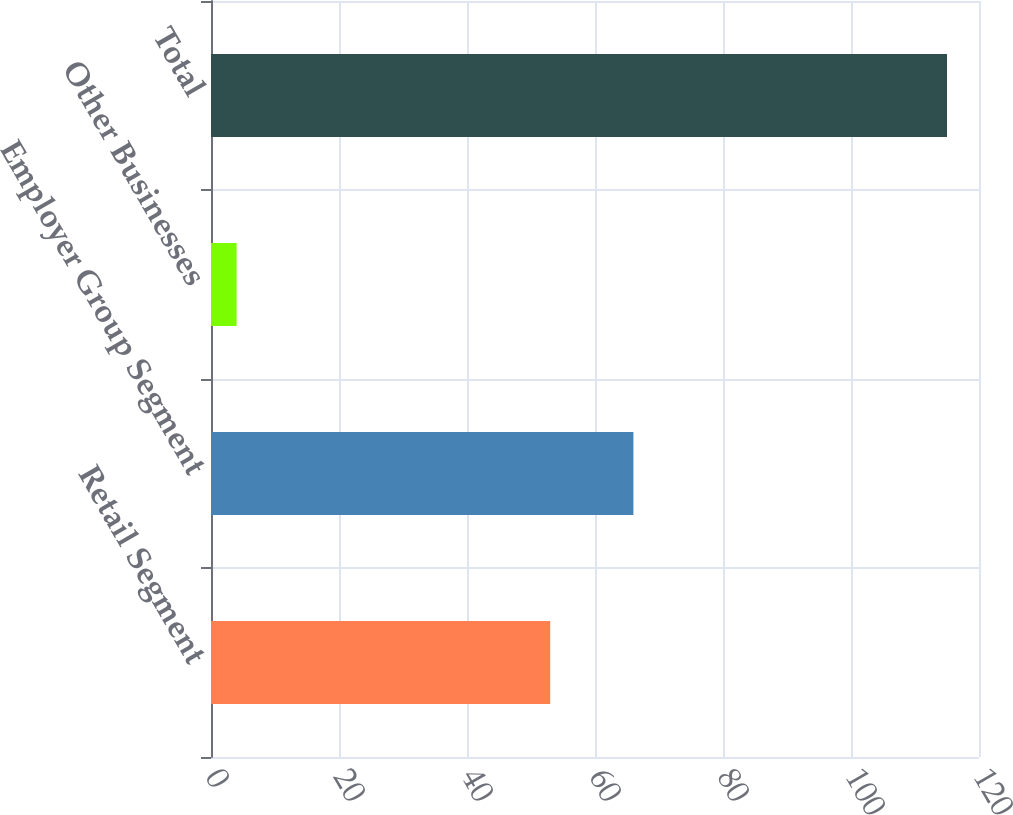Convert chart to OTSL. <chart><loc_0><loc_0><loc_500><loc_500><bar_chart><fcel>Retail Segment<fcel>Employer Group Segment<fcel>Other Businesses<fcel>Total<nl><fcel>53<fcel>66<fcel>4<fcel>115<nl></chart> 